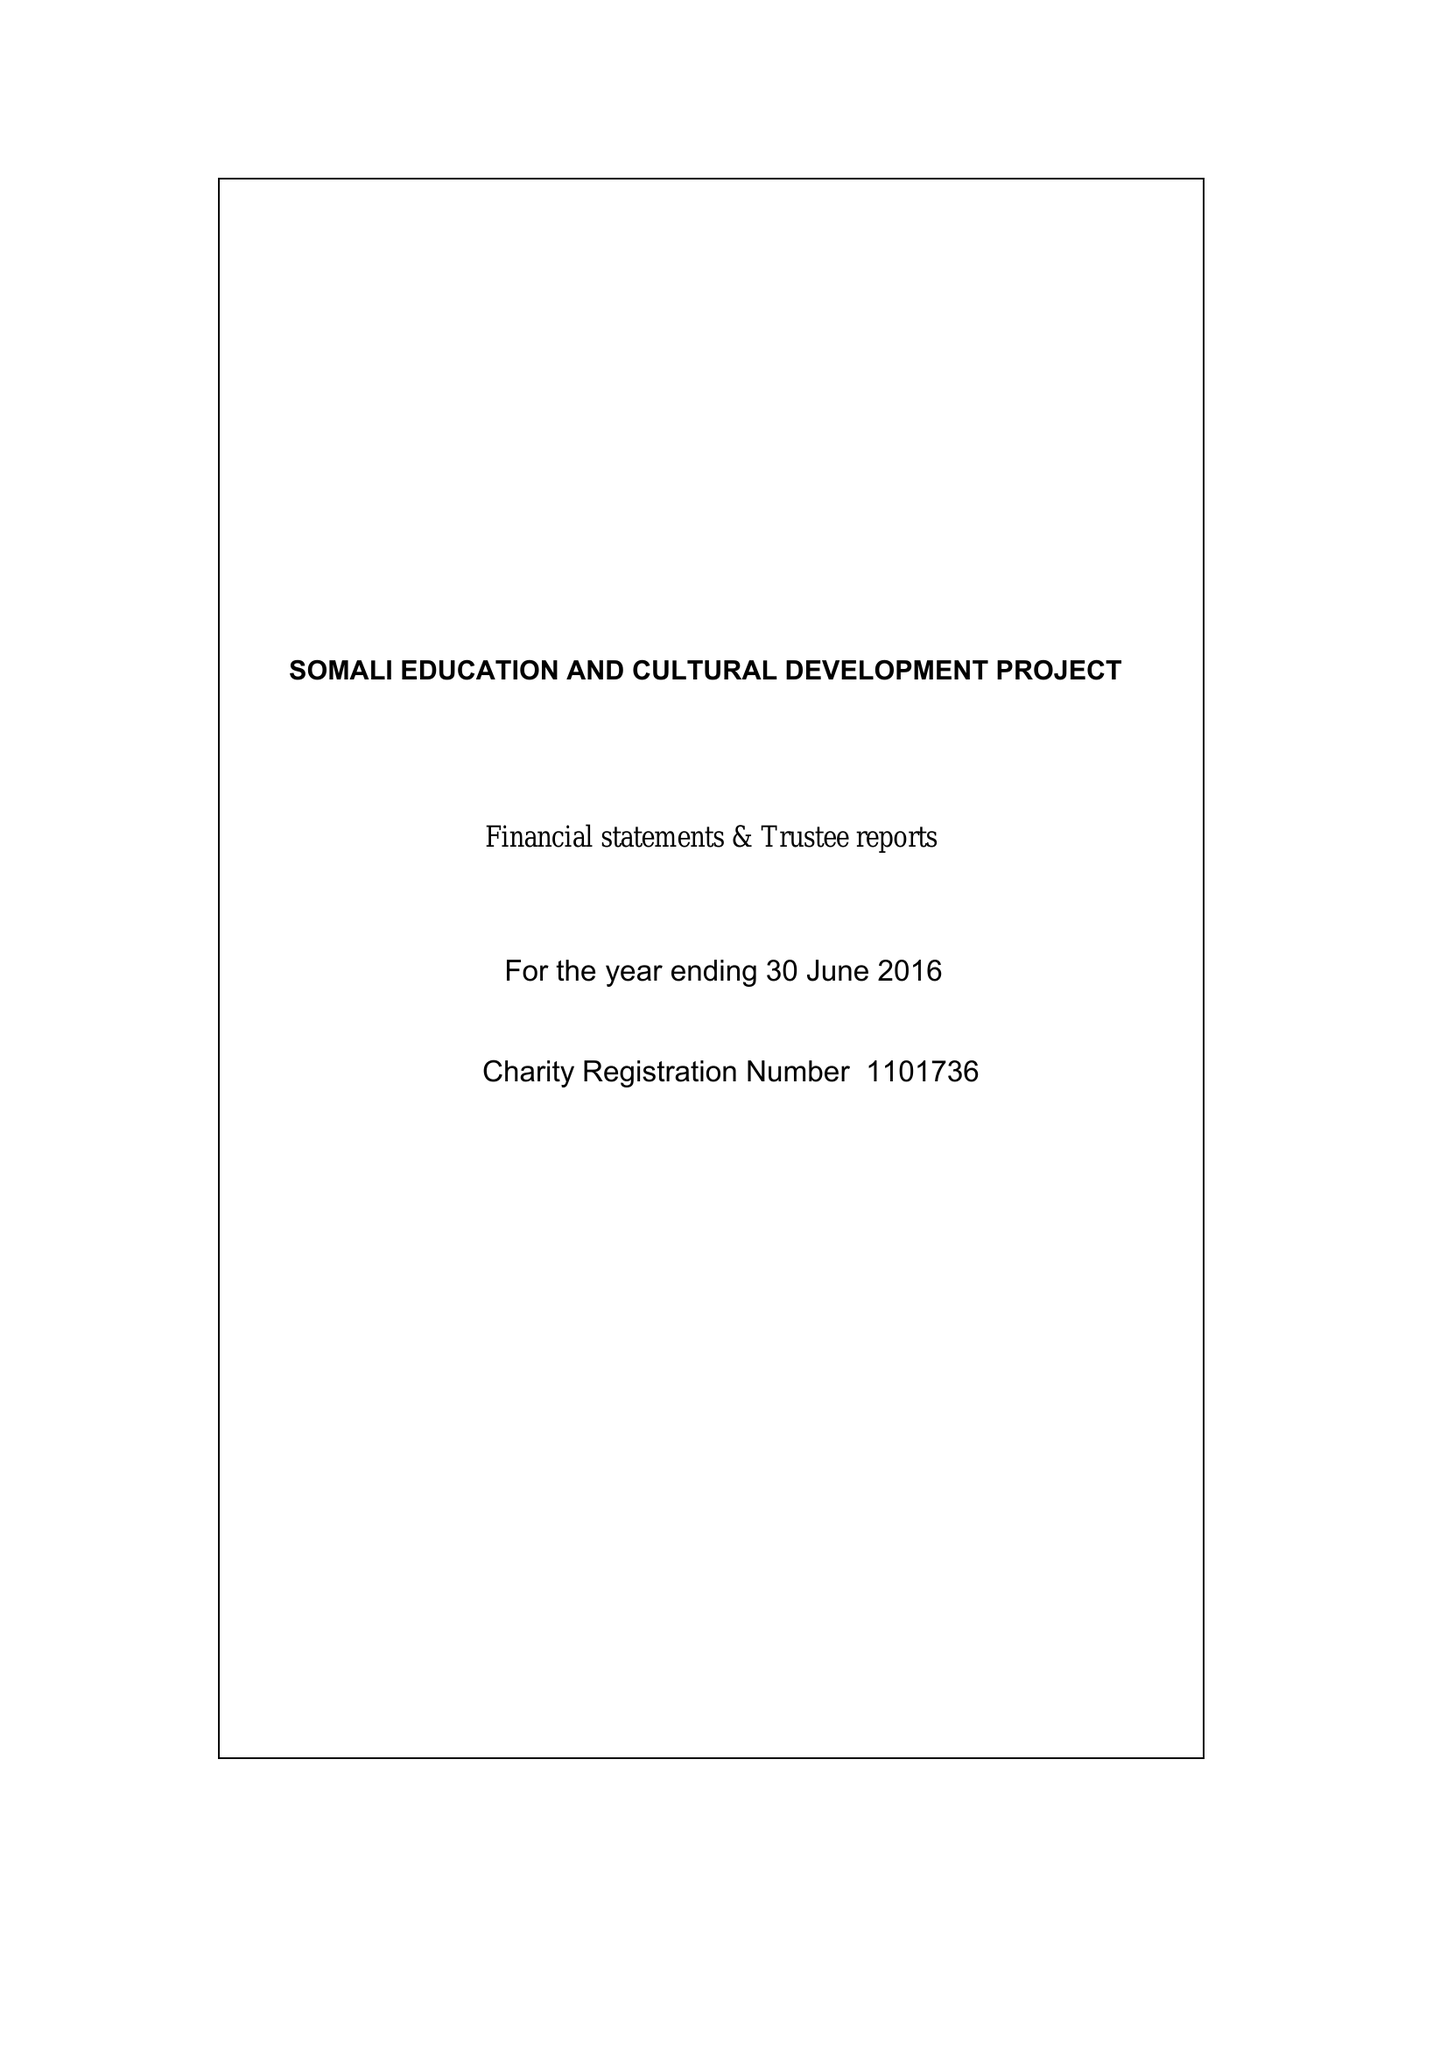What is the value for the charity_number?
Answer the question using a single word or phrase. 1101736 